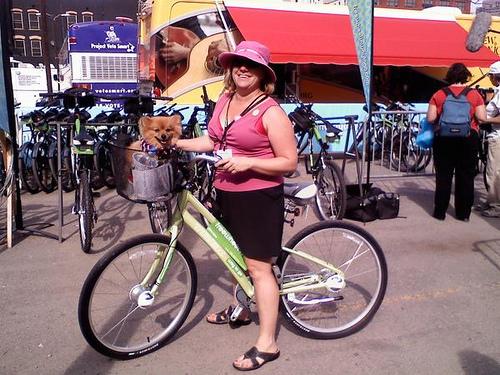Does the person have tie or velcro shoes?
Be succinct. Neither. How many tattoos does the woman have on her arm?
Keep it brief. 0. Is the woman on the bike wearing a dress?
Short answer required. No. Is the woman with the hat making a smoothie?
Answer briefly. No. Does the woman's hat match her shirt?
Keep it brief. Yes. How many wheels are visible?
Keep it brief. Many. What is in the basket of the bike?
Short answer required. Dog. What color is the woman's bike?
Give a very brief answer. Green. 